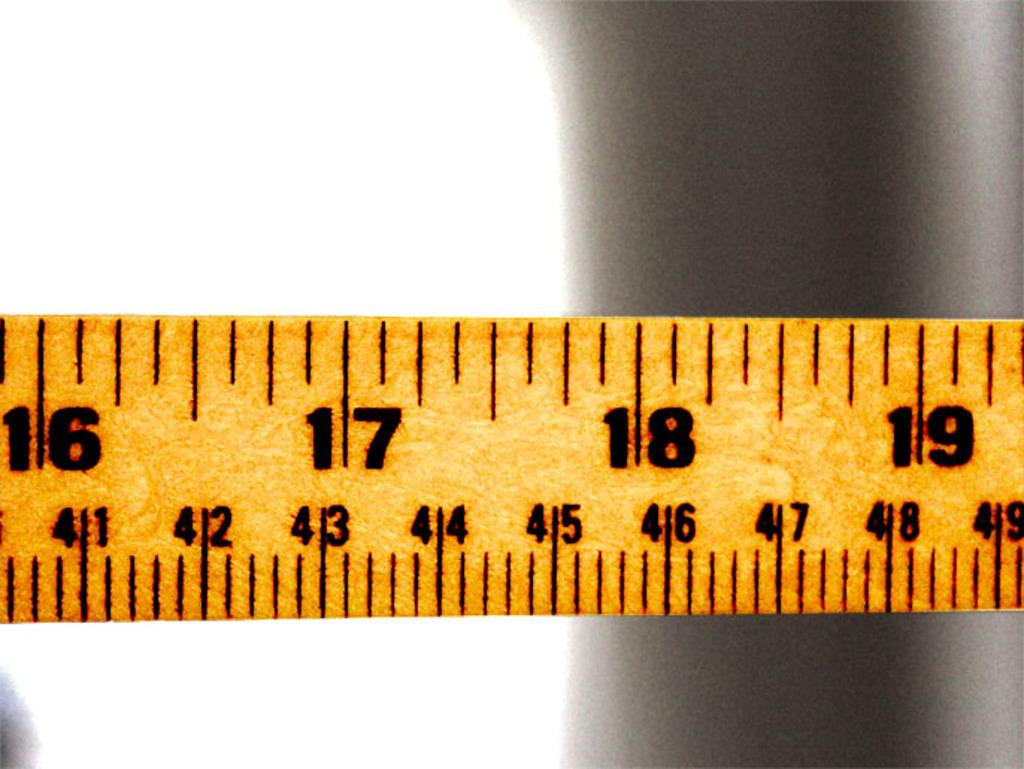What's the lowest large number on the ruler?
Provide a short and direct response. 16. What is the highest number on the ruler?
Offer a very short reply. 19. 